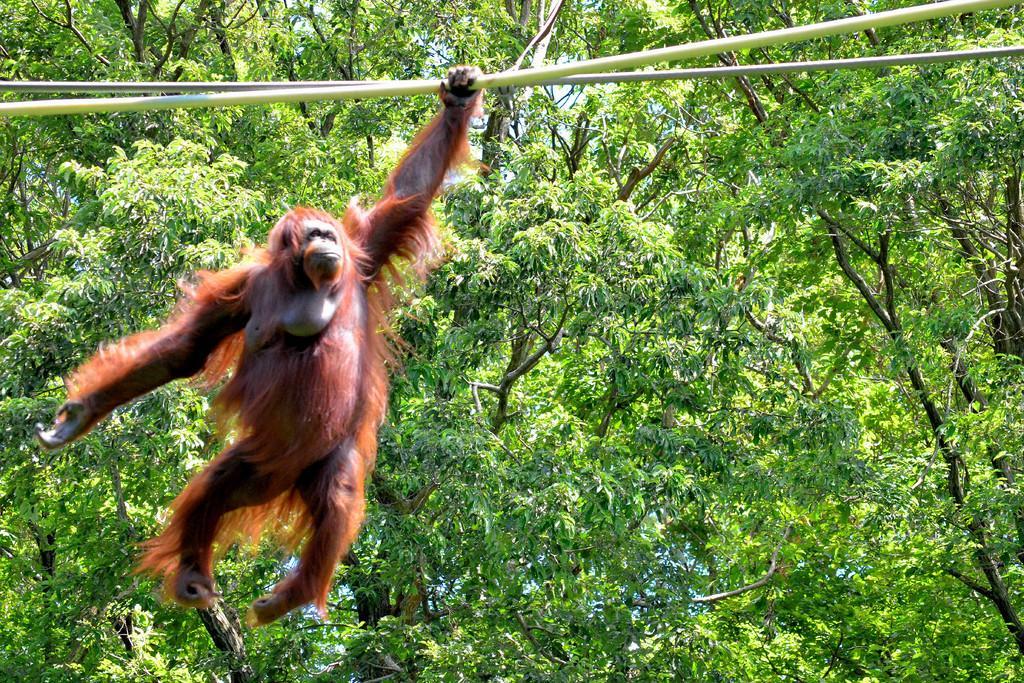Describe this image in one or two sentences. In this image I can see monkey is holding the white color pole. We can see trees. Monkey is in brown color. 